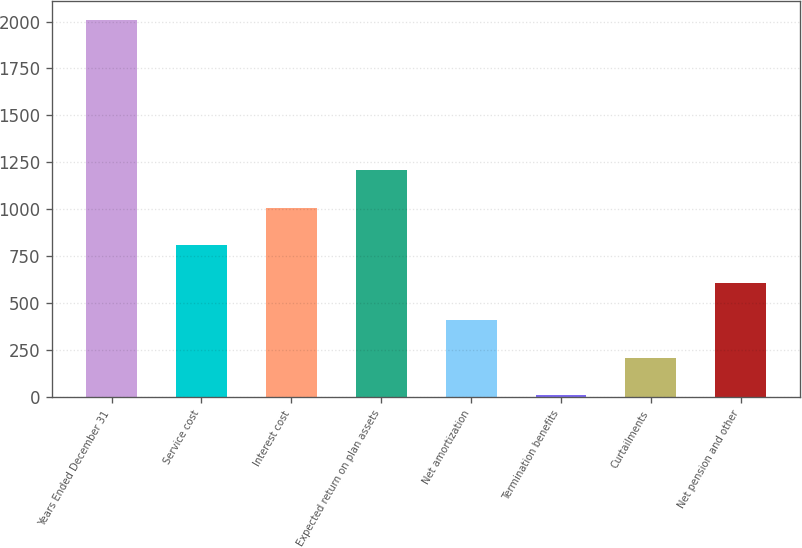Convert chart to OTSL. <chart><loc_0><loc_0><loc_500><loc_500><bar_chart><fcel>Years Ended December 31<fcel>Service cost<fcel>Interest cost<fcel>Expected return on plan assets<fcel>Net amortization<fcel>Termination benefits<fcel>Curtailments<fcel>Net pension and other<nl><fcel>2008<fcel>809.92<fcel>1009.6<fcel>1209.28<fcel>410.56<fcel>11.2<fcel>210.88<fcel>610.24<nl></chart> 